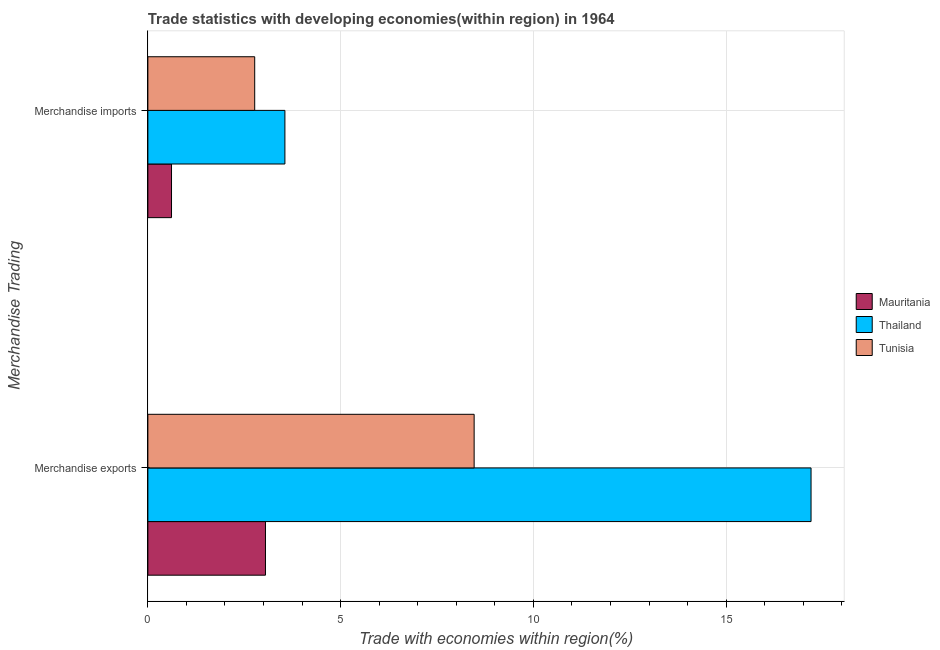How many different coloured bars are there?
Provide a short and direct response. 3. Are the number of bars per tick equal to the number of legend labels?
Make the answer very short. Yes. How many bars are there on the 2nd tick from the top?
Give a very brief answer. 3. What is the label of the 1st group of bars from the top?
Your response must be concise. Merchandise imports. What is the merchandise imports in Mauritania?
Your response must be concise. 0.61. Across all countries, what is the maximum merchandise imports?
Offer a terse response. 3.55. Across all countries, what is the minimum merchandise exports?
Provide a short and direct response. 3.05. In which country was the merchandise exports maximum?
Your answer should be compact. Thailand. In which country was the merchandise exports minimum?
Keep it short and to the point. Mauritania. What is the total merchandise exports in the graph?
Offer a terse response. 28.71. What is the difference between the merchandise imports in Thailand and that in Tunisia?
Keep it short and to the point. 0.78. What is the difference between the merchandise imports in Thailand and the merchandise exports in Mauritania?
Your answer should be compact. 0.5. What is the average merchandise imports per country?
Make the answer very short. 2.31. What is the difference between the merchandise exports and merchandise imports in Tunisia?
Provide a short and direct response. 5.69. What is the ratio of the merchandise exports in Tunisia to that in Mauritania?
Keep it short and to the point. 2.77. Is the merchandise imports in Tunisia less than that in Thailand?
Keep it short and to the point. Yes. In how many countries, is the merchandise imports greater than the average merchandise imports taken over all countries?
Give a very brief answer. 2. What does the 1st bar from the top in Merchandise imports represents?
Your response must be concise. Tunisia. What does the 1st bar from the bottom in Merchandise imports represents?
Your answer should be compact. Mauritania. How many bars are there?
Your answer should be compact. 6. Are all the bars in the graph horizontal?
Provide a succinct answer. Yes. How many countries are there in the graph?
Offer a very short reply. 3. What is the difference between two consecutive major ticks on the X-axis?
Your answer should be very brief. 5. Are the values on the major ticks of X-axis written in scientific E-notation?
Offer a very short reply. No. Does the graph contain any zero values?
Your answer should be very brief. No. Where does the legend appear in the graph?
Offer a terse response. Center right. How many legend labels are there?
Give a very brief answer. 3. How are the legend labels stacked?
Offer a very short reply. Vertical. What is the title of the graph?
Your answer should be compact. Trade statistics with developing economies(within region) in 1964. Does "Israel" appear as one of the legend labels in the graph?
Provide a short and direct response. No. What is the label or title of the X-axis?
Ensure brevity in your answer.  Trade with economies within region(%). What is the label or title of the Y-axis?
Keep it short and to the point. Merchandise Trading. What is the Trade with economies within region(%) in Mauritania in Merchandise exports?
Give a very brief answer. 3.05. What is the Trade with economies within region(%) in Thailand in Merchandise exports?
Your answer should be very brief. 17.2. What is the Trade with economies within region(%) in Tunisia in Merchandise exports?
Your response must be concise. 8.46. What is the Trade with economies within region(%) in Mauritania in Merchandise imports?
Provide a succinct answer. 0.61. What is the Trade with economies within region(%) in Thailand in Merchandise imports?
Your answer should be very brief. 3.55. What is the Trade with economies within region(%) in Tunisia in Merchandise imports?
Your response must be concise. 2.77. Across all Merchandise Trading, what is the maximum Trade with economies within region(%) of Mauritania?
Your response must be concise. 3.05. Across all Merchandise Trading, what is the maximum Trade with economies within region(%) of Thailand?
Ensure brevity in your answer.  17.2. Across all Merchandise Trading, what is the maximum Trade with economies within region(%) in Tunisia?
Your response must be concise. 8.46. Across all Merchandise Trading, what is the minimum Trade with economies within region(%) of Mauritania?
Provide a short and direct response. 0.61. Across all Merchandise Trading, what is the minimum Trade with economies within region(%) of Thailand?
Offer a terse response. 3.55. Across all Merchandise Trading, what is the minimum Trade with economies within region(%) of Tunisia?
Offer a very short reply. 2.77. What is the total Trade with economies within region(%) in Mauritania in the graph?
Provide a short and direct response. 3.66. What is the total Trade with economies within region(%) of Thailand in the graph?
Make the answer very short. 20.76. What is the total Trade with economies within region(%) in Tunisia in the graph?
Give a very brief answer. 11.23. What is the difference between the Trade with economies within region(%) in Mauritania in Merchandise exports and that in Merchandise imports?
Your answer should be very brief. 2.44. What is the difference between the Trade with economies within region(%) of Thailand in Merchandise exports and that in Merchandise imports?
Offer a terse response. 13.65. What is the difference between the Trade with economies within region(%) in Tunisia in Merchandise exports and that in Merchandise imports?
Keep it short and to the point. 5.69. What is the difference between the Trade with economies within region(%) in Mauritania in Merchandise exports and the Trade with economies within region(%) in Thailand in Merchandise imports?
Provide a short and direct response. -0.5. What is the difference between the Trade with economies within region(%) of Mauritania in Merchandise exports and the Trade with economies within region(%) of Tunisia in Merchandise imports?
Keep it short and to the point. 0.28. What is the difference between the Trade with economies within region(%) of Thailand in Merchandise exports and the Trade with economies within region(%) of Tunisia in Merchandise imports?
Offer a very short reply. 14.43. What is the average Trade with economies within region(%) of Mauritania per Merchandise Trading?
Your answer should be very brief. 1.83. What is the average Trade with economies within region(%) in Thailand per Merchandise Trading?
Provide a succinct answer. 10.38. What is the average Trade with economies within region(%) in Tunisia per Merchandise Trading?
Keep it short and to the point. 5.62. What is the difference between the Trade with economies within region(%) of Mauritania and Trade with economies within region(%) of Thailand in Merchandise exports?
Offer a terse response. -14.15. What is the difference between the Trade with economies within region(%) of Mauritania and Trade with economies within region(%) of Tunisia in Merchandise exports?
Give a very brief answer. -5.41. What is the difference between the Trade with economies within region(%) of Thailand and Trade with economies within region(%) of Tunisia in Merchandise exports?
Make the answer very short. 8.74. What is the difference between the Trade with economies within region(%) of Mauritania and Trade with economies within region(%) of Thailand in Merchandise imports?
Your answer should be very brief. -2.94. What is the difference between the Trade with economies within region(%) in Mauritania and Trade with economies within region(%) in Tunisia in Merchandise imports?
Provide a short and direct response. -2.16. What is the difference between the Trade with economies within region(%) of Thailand and Trade with economies within region(%) of Tunisia in Merchandise imports?
Your answer should be compact. 0.78. What is the ratio of the Trade with economies within region(%) in Mauritania in Merchandise exports to that in Merchandise imports?
Provide a succinct answer. 4.97. What is the ratio of the Trade with economies within region(%) of Thailand in Merchandise exports to that in Merchandise imports?
Provide a short and direct response. 4.84. What is the ratio of the Trade with economies within region(%) in Tunisia in Merchandise exports to that in Merchandise imports?
Provide a short and direct response. 3.05. What is the difference between the highest and the second highest Trade with economies within region(%) of Mauritania?
Keep it short and to the point. 2.44. What is the difference between the highest and the second highest Trade with economies within region(%) in Thailand?
Your response must be concise. 13.65. What is the difference between the highest and the second highest Trade with economies within region(%) of Tunisia?
Provide a short and direct response. 5.69. What is the difference between the highest and the lowest Trade with economies within region(%) in Mauritania?
Your response must be concise. 2.44. What is the difference between the highest and the lowest Trade with economies within region(%) in Thailand?
Keep it short and to the point. 13.65. What is the difference between the highest and the lowest Trade with economies within region(%) of Tunisia?
Make the answer very short. 5.69. 